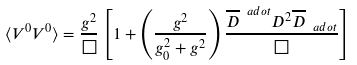<formula> <loc_0><loc_0><loc_500><loc_500>\langle V ^ { 0 } V ^ { 0 } \rangle = \frac { g ^ { 2 } } { \Box } \left [ 1 + \left ( \frac { g ^ { 2 } } { g _ { 0 } ^ { 2 } + g ^ { 2 } } \right ) \frac { \overline { D } ^ { \ a d o t } D ^ { 2 } \overline { D } _ { \ a d o t } } { \Box } \right ]</formula> 